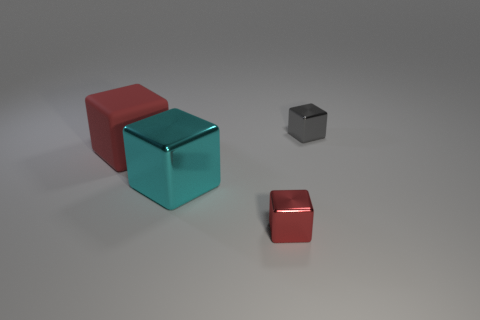What is the color of the tiny metallic cube that is in front of the red object behind the cyan shiny cube? The tiny metallic cube appears to be silver or grey, which is characteristic of many metals. This color stands out as being distinct from the more vivid shades of red and cyan of the other objects in the image. 